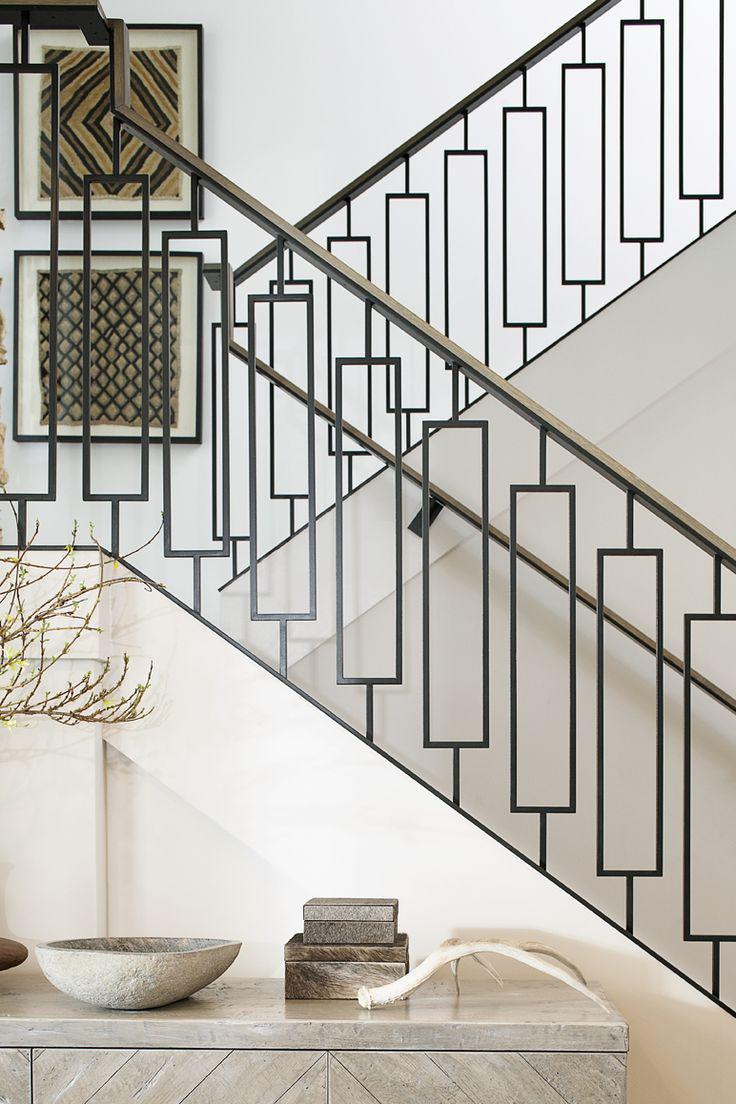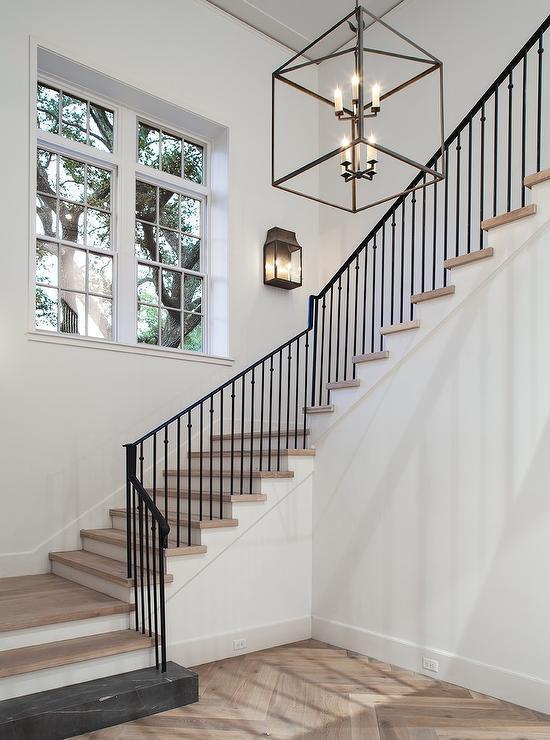The first image is the image on the left, the second image is the image on the right. Analyze the images presented: Is the assertion "There is at least one staircase with horizontal railings." valid? Answer yes or no. No. 